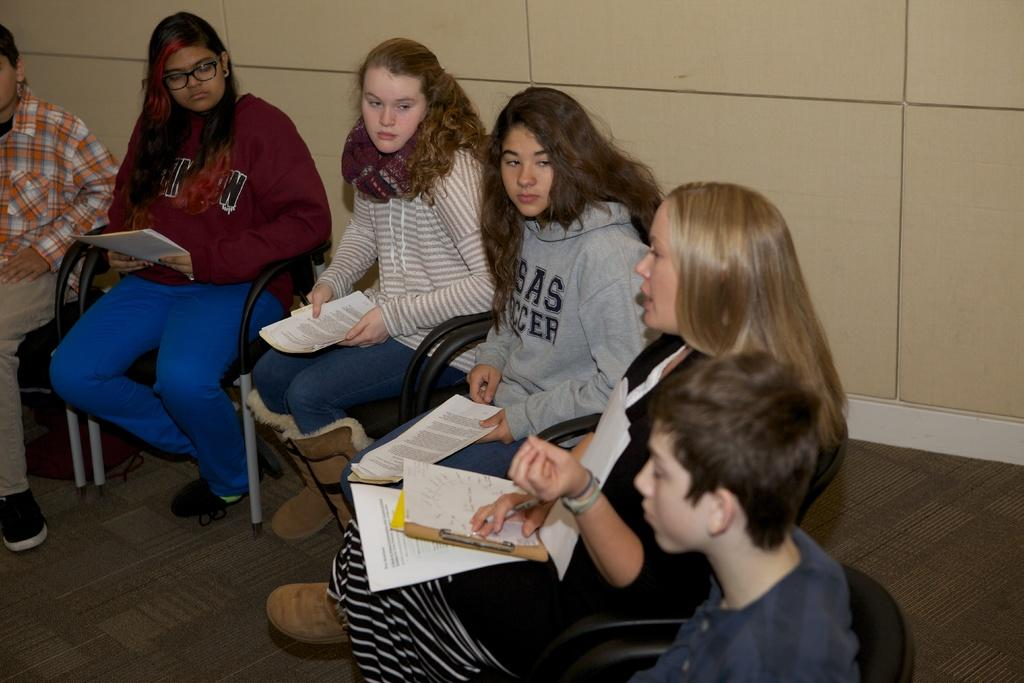Who or what can be seen in the image? There are people in the image. What are the people doing in the image? The people are sitting on chairs. What are the people holding in their hands? The people are holding books in their hands. How many buns are on the table in the image? There is no table or buns present in the image; it only shows people sitting on chairs and holding books. 